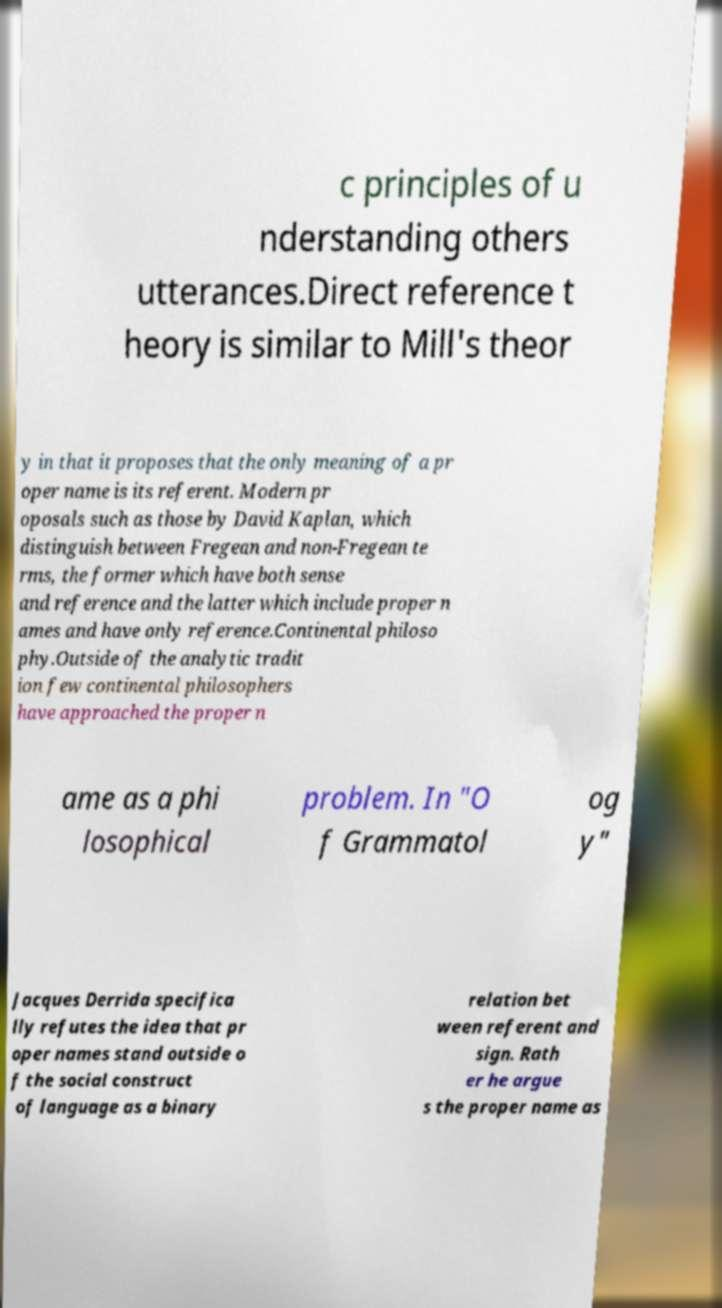Please identify and transcribe the text found in this image. c principles of u nderstanding others utterances.Direct reference t heory is similar to Mill's theor y in that it proposes that the only meaning of a pr oper name is its referent. Modern pr oposals such as those by David Kaplan, which distinguish between Fregean and non-Fregean te rms, the former which have both sense and reference and the latter which include proper n ames and have only reference.Continental philoso phy.Outside of the analytic tradit ion few continental philosophers have approached the proper n ame as a phi losophical problem. In "O f Grammatol og y" Jacques Derrida specifica lly refutes the idea that pr oper names stand outside o f the social construct of language as a binary relation bet ween referent and sign. Rath er he argue s the proper name as 